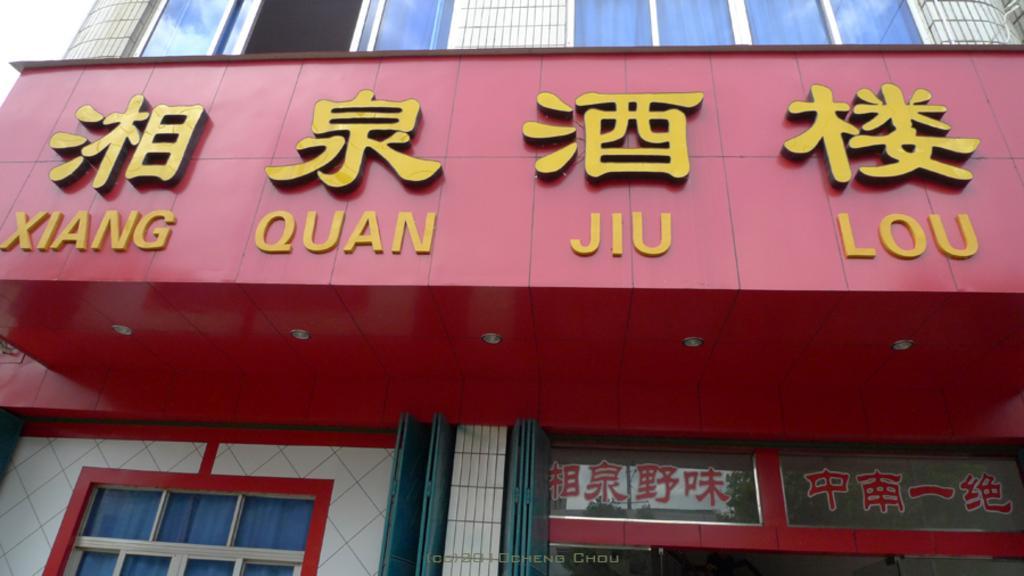In one or two sentences, can you explain what this image depicts? In this image I can see a building which is red, blue and white in color. I can see a huge red colored board, few lights to it and something is written with yellow color on the board. In the background I can see the sky. 